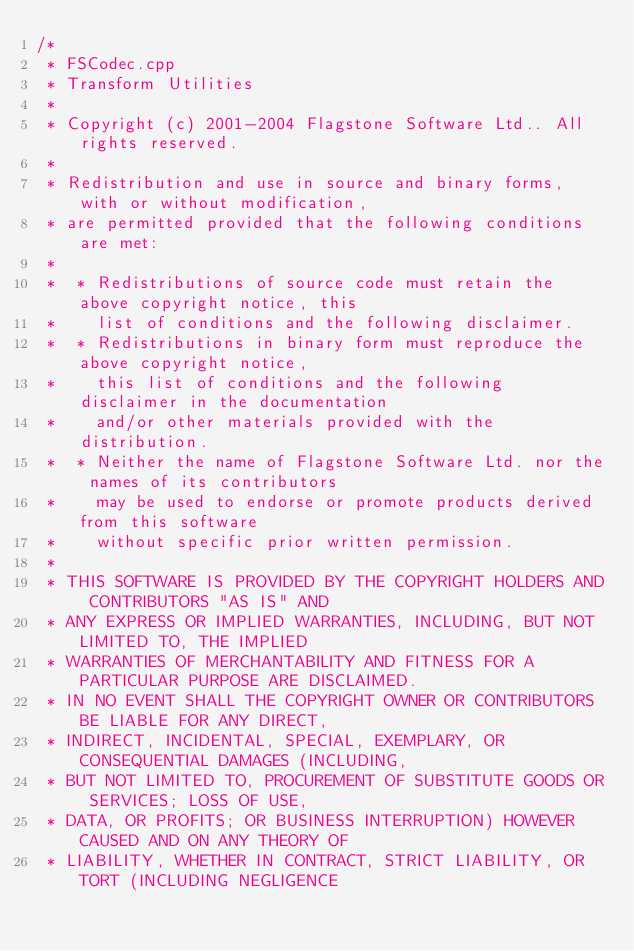<code> <loc_0><loc_0><loc_500><loc_500><_C++_>/*
 * FSCodec.cpp
 * Transform Utilities
 *
 * Copyright (c) 2001-2004 Flagstone Software Ltd.. All rights reserved.
 *
 * Redistribution and use in source and binary forms, with or without modification,
 * are permitted provided that the following conditions are met:
 *
 *  * Redistributions of source code must retain the above copyright notice, this
 *    list of conditions and the following disclaimer.
 *  * Redistributions in binary form must reproduce the above copyright notice,
 *    this list of conditions and the following disclaimer in the documentation
 *    and/or other materials provided with the distribution.
 *  * Neither the name of Flagstone Software Ltd. nor the names of its contributors
 *    may be used to endorse or promote products derived from this software
 *    without specific prior written permission.
 *
 * THIS SOFTWARE IS PROVIDED BY THE COPYRIGHT HOLDERS AND CONTRIBUTORS "AS IS" AND
 * ANY EXPRESS OR IMPLIED WARRANTIES, INCLUDING, BUT NOT LIMITED TO, THE IMPLIED
 * WARRANTIES OF MERCHANTABILITY AND FITNESS FOR A PARTICULAR PURPOSE ARE DISCLAIMED.
 * IN NO EVENT SHALL THE COPYRIGHT OWNER OR CONTRIBUTORS BE LIABLE FOR ANY DIRECT,
 * INDIRECT, INCIDENTAL, SPECIAL, EXEMPLARY, OR CONSEQUENTIAL DAMAGES (INCLUDING,
 * BUT NOT LIMITED TO, PROCUREMENT OF SUBSTITUTE GOODS OR SERVICES; LOSS OF USE,
 * DATA, OR PROFITS; OR BUSINESS INTERRUPTION) HOWEVER CAUSED AND ON ANY THEORY OF
 * LIABILITY, WHETHER IN CONTRACT, STRICT LIABILITY, OR TORT (INCLUDING NEGLIGENCE</code> 